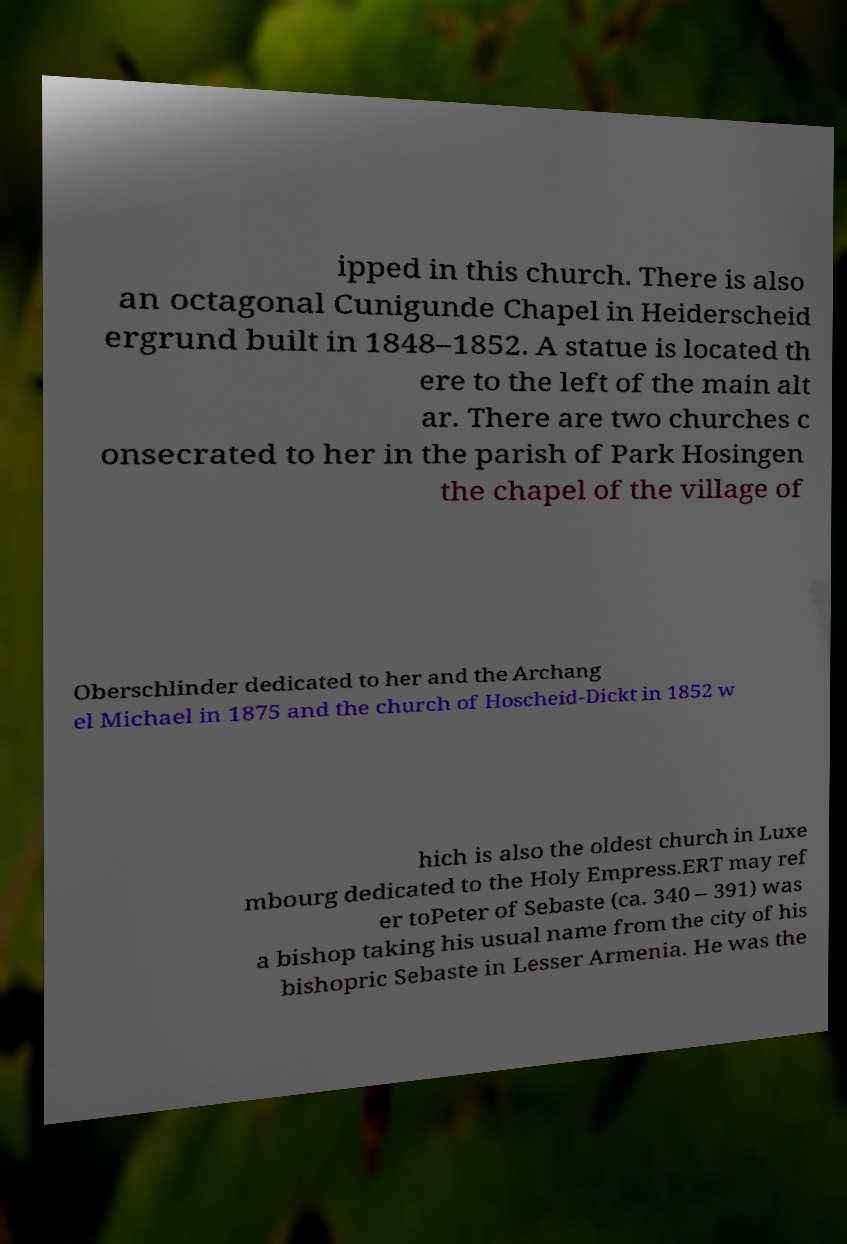What messages or text are displayed in this image? I need them in a readable, typed format. ipped in this church. There is also an octagonal Cunigunde Chapel in Heiderscheid ergrund built in 1848–1852. A statue is located th ere to the left of the main alt ar. There are two churches c onsecrated to her in the parish of Park Hosingen the chapel of the village of Oberschlinder dedicated to her and the Archang el Michael in 1875 and the church of Hoscheid-Dickt in 1852 w hich is also the oldest church in Luxe mbourg dedicated to the Holy Empress.ERT may ref er toPeter of Sebaste (ca. 340 – 391) was a bishop taking his usual name from the city of his bishopric Sebaste in Lesser Armenia. He was the 